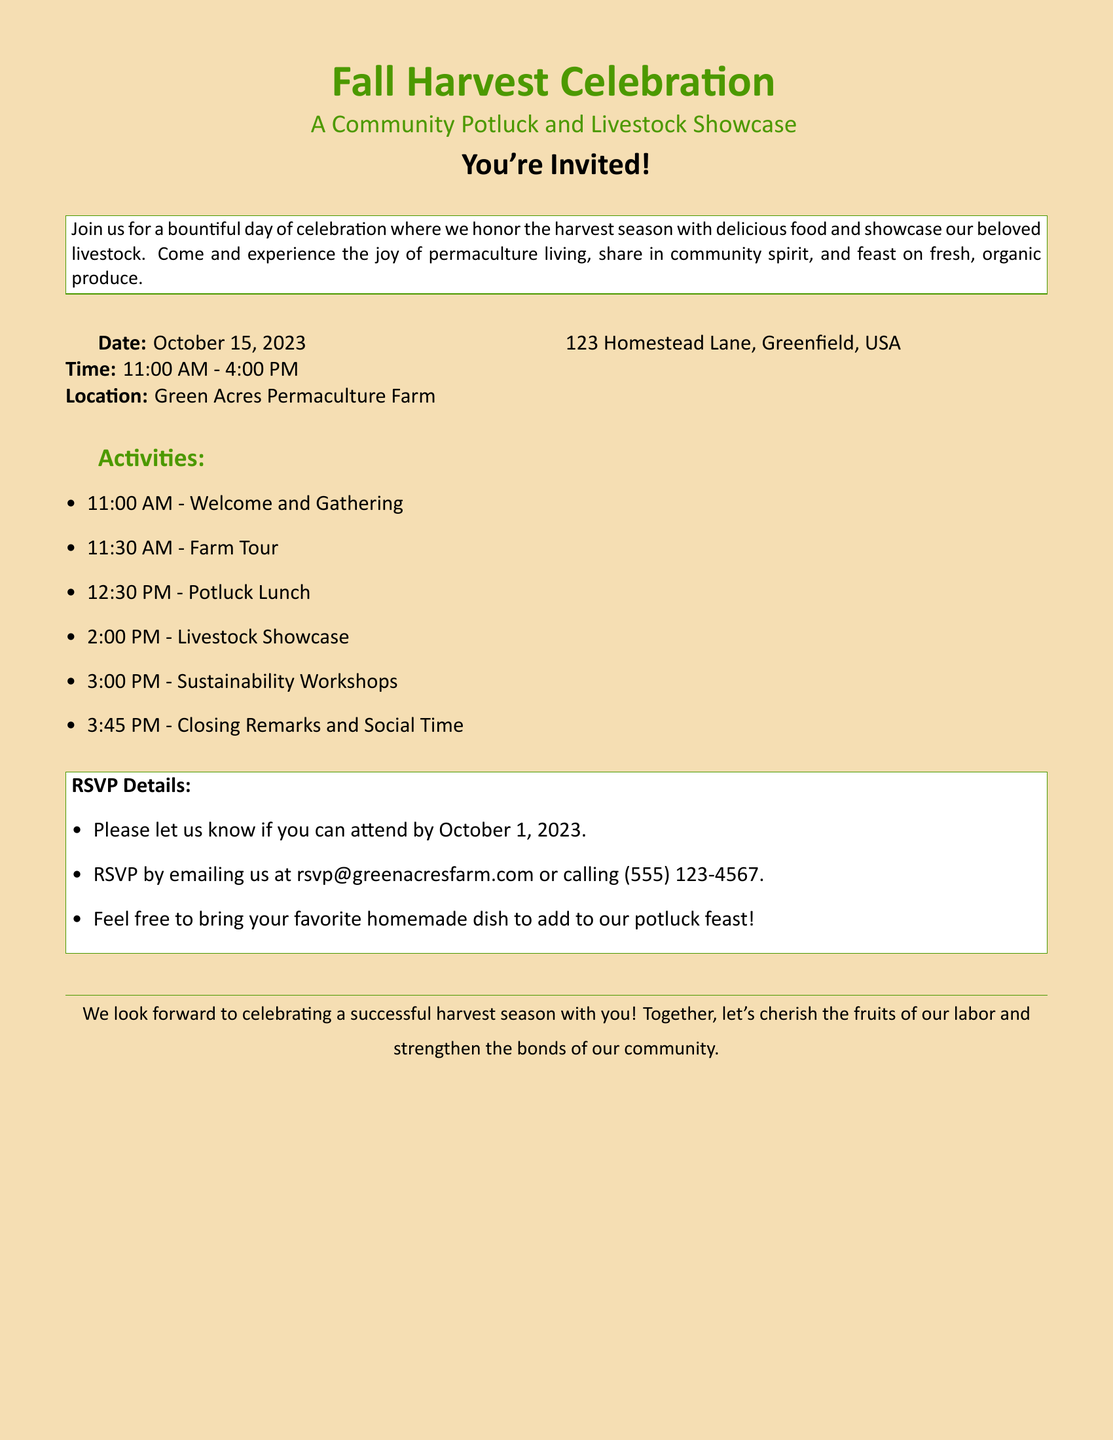What is the date of the event? The date is explicitly mentioned in the document under "Date".
Answer: October 15, 2023 What is the time range of the event? The time is provided in the "Time" section, indicating the start and end times.
Answer: 11:00 AM - 4:00 PM Where is the Fall Harvest Celebration taking place? The location is stated under "Location" in the address format.
Answer: Green Acres Permaculture Farm What is one of the activities scheduled at 2:00 PM? The activities are listed chronologically, and the one at 2:00 PM is specified.
Answer: Livestock Showcase By when should we RSVP? The RSVP deadline is directly mentioned in the RSVP Details section of the document.
Answer: October 1, 2023 What type of dish can attendees bring? The document invites attendees to contribute to the potluck, specifying the nature of the dish.
Answer: Homemade dish How can attendees RSVP? The document provides two methods for RSVP in the "RSVP Details".
Answer: Email or call What is one of the final activities listed? The last activity is noted towards the end of the activities list.
Answer: Closing Remarks and Social Time How many hours does the event span? Calculation is based on the starting and ending times provided in the event details.
Answer: 5 hours 